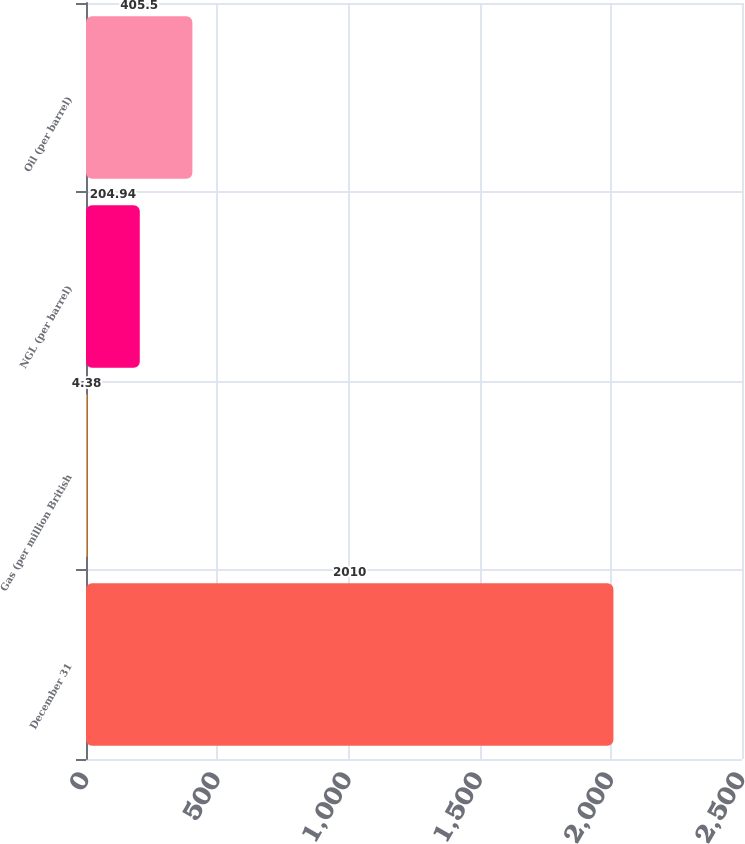Convert chart. <chart><loc_0><loc_0><loc_500><loc_500><bar_chart><fcel>December 31<fcel>Gas (per million British<fcel>NGL (per barrel)<fcel>Oil (per barrel)<nl><fcel>2010<fcel>4.38<fcel>204.94<fcel>405.5<nl></chart> 